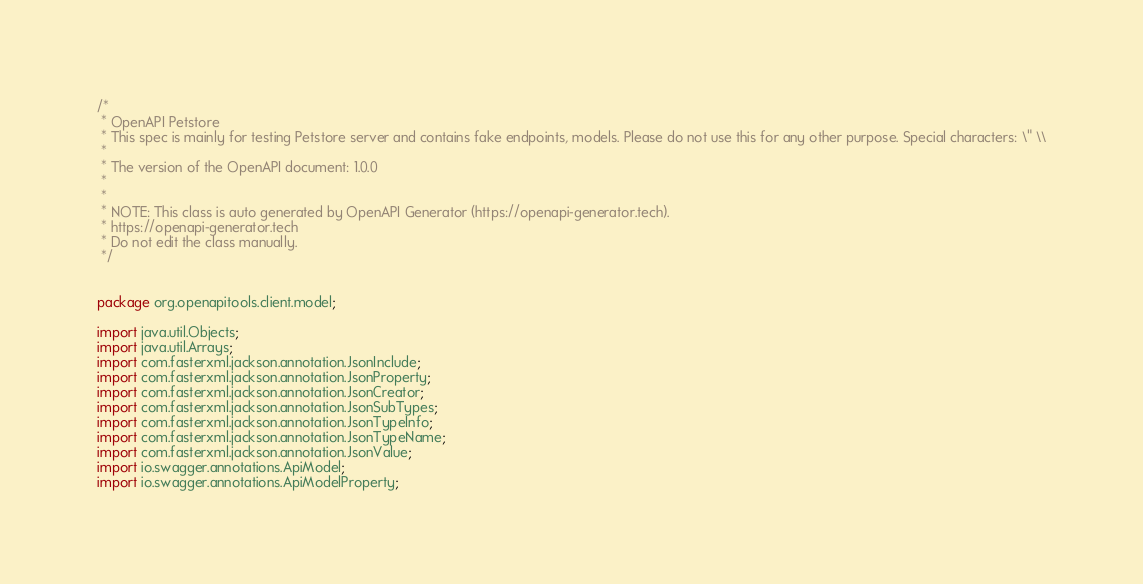<code> <loc_0><loc_0><loc_500><loc_500><_Java_>/*
 * OpenAPI Petstore
 * This spec is mainly for testing Petstore server and contains fake endpoints, models. Please do not use this for any other purpose. Special characters: \" \\
 *
 * The version of the OpenAPI document: 1.0.0
 * 
 *
 * NOTE: This class is auto generated by OpenAPI Generator (https://openapi-generator.tech).
 * https://openapi-generator.tech
 * Do not edit the class manually.
 */


package org.openapitools.client.model;

import java.util.Objects;
import java.util.Arrays;
import com.fasterxml.jackson.annotation.JsonInclude;
import com.fasterxml.jackson.annotation.JsonProperty;
import com.fasterxml.jackson.annotation.JsonCreator;
import com.fasterxml.jackson.annotation.JsonSubTypes;
import com.fasterxml.jackson.annotation.JsonTypeInfo;
import com.fasterxml.jackson.annotation.JsonTypeName;
import com.fasterxml.jackson.annotation.JsonValue;
import io.swagger.annotations.ApiModel;
import io.swagger.annotations.ApiModelProperty;</code> 